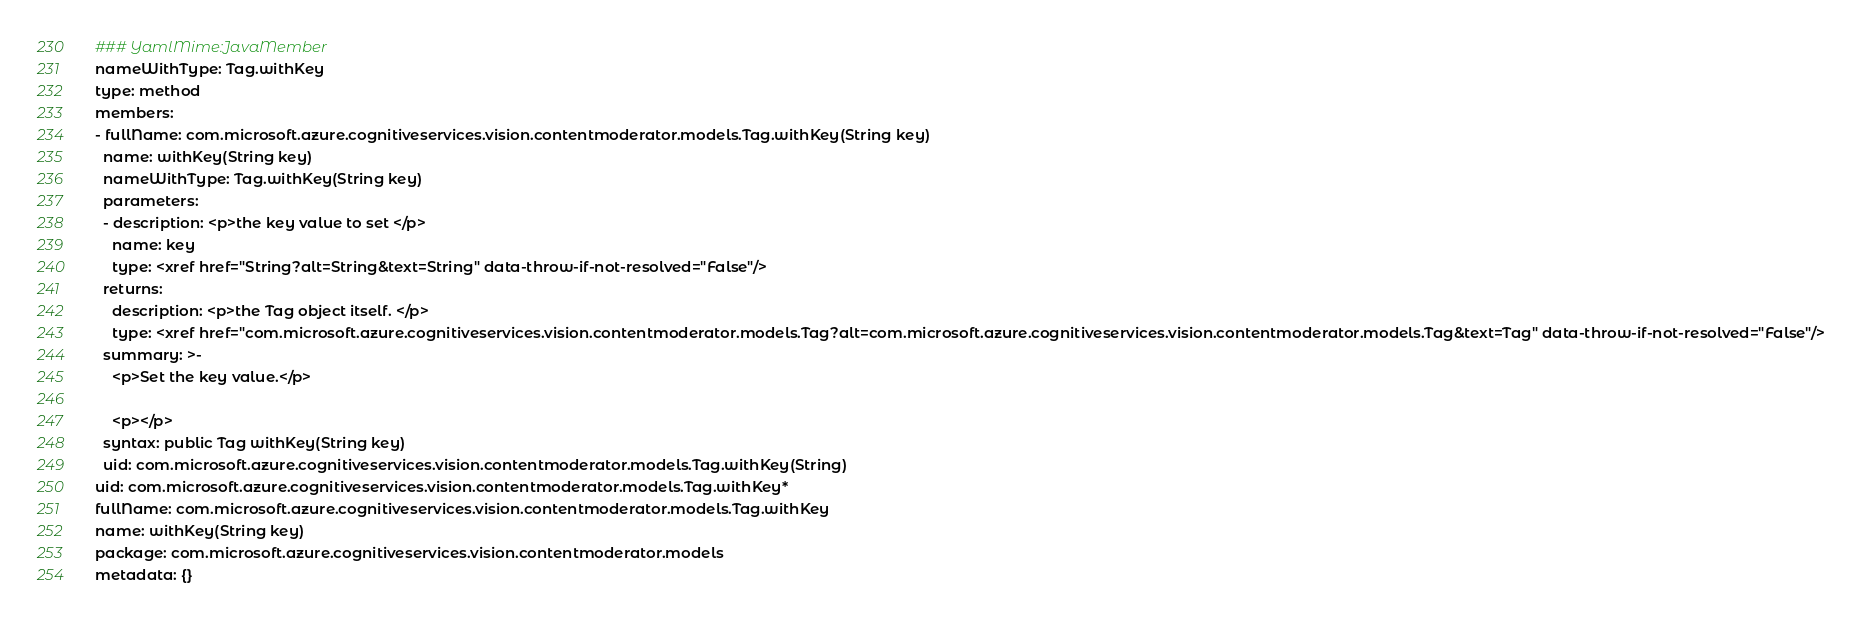Convert code to text. <code><loc_0><loc_0><loc_500><loc_500><_YAML_>### YamlMime:JavaMember
nameWithType: Tag.withKey
type: method
members:
- fullName: com.microsoft.azure.cognitiveservices.vision.contentmoderator.models.Tag.withKey(String key)
  name: withKey(String key)
  nameWithType: Tag.withKey(String key)
  parameters:
  - description: <p>the key value to set </p>
    name: key
    type: <xref href="String?alt=String&text=String" data-throw-if-not-resolved="False"/>
  returns:
    description: <p>the Tag object itself. </p>
    type: <xref href="com.microsoft.azure.cognitiveservices.vision.contentmoderator.models.Tag?alt=com.microsoft.azure.cognitiveservices.vision.contentmoderator.models.Tag&text=Tag" data-throw-if-not-resolved="False"/>
  summary: >-
    <p>Set the key value.</p>

    <p></p>
  syntax: public Tag withKey(String key)
  uid: com.microsoft.azure.cognitiveservices.vision.contentmoderator.models.Tag.withKey(String)
uid: com.microsoft.azure.cognitiveservices.vision.contentmoderator.models.Tag.withKey*
fullName: com.microsoft.azure.cognitiveservices.vision.contentmoderator.models.Tag.withKey
name: withKey(String key)
package: com.microsoft.azure.cognitiveservices.vision.contentmoderator.models
metadata: {}
</code> 